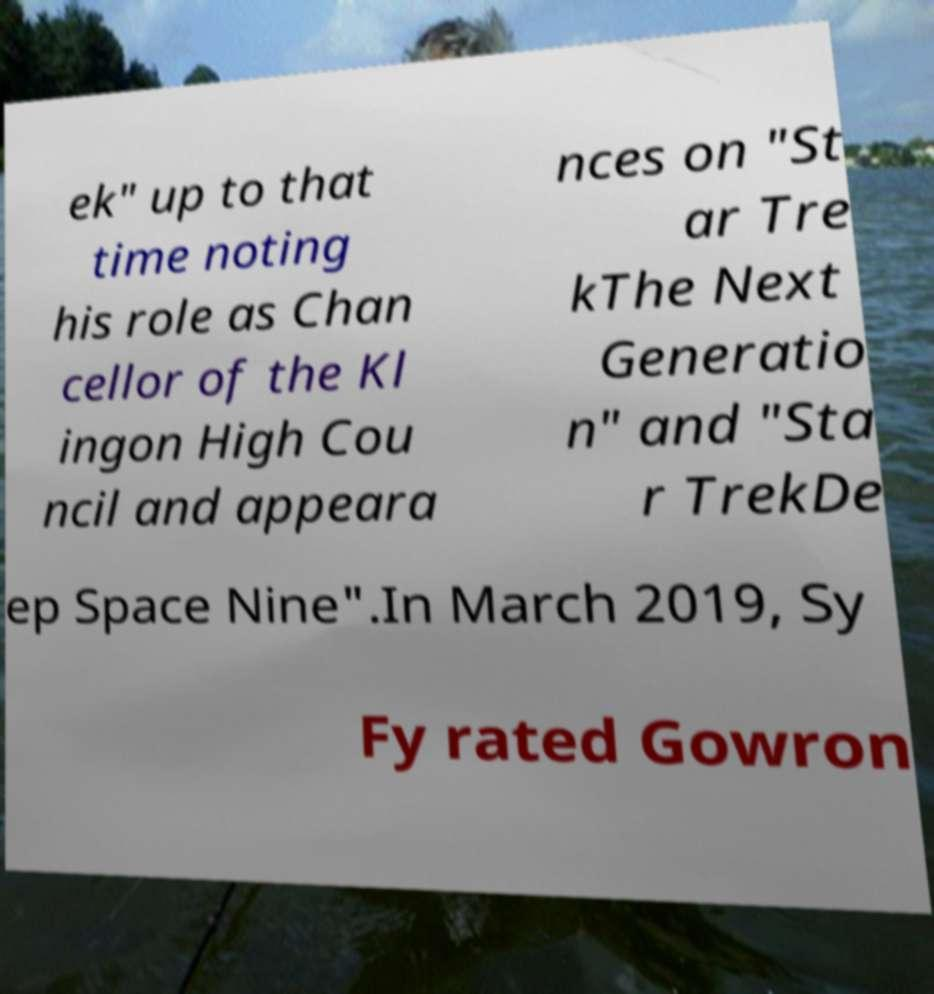There's text embedded in this image that I need extracted. Can you transcribe it verbatim? ek" up to that time noting his role as Chan cellor of the Kl ingon High Cou ncil and appeara nces on "St ar Tre kThe Next Generatio n" and "Sta r TrekDe ep Space Nine".In March 2019, Sy Fy rated Gowron 